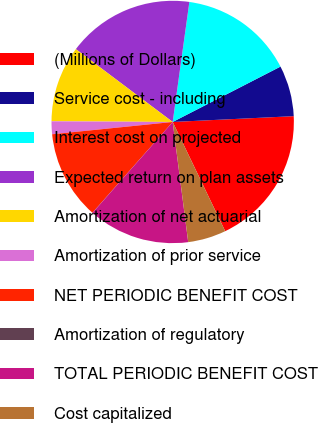Convert chart to OTSL. <chart><loc_0><loc_0><loc_500><loc_500><pie_chart><fcel>(Millions of Dollars)<fcel>Service cost - including<fcel>Interest cost on projected<fcel>Expected return on plan assets<fcel>Amortization of net actuarial<fcel>Amortization of prior service<fcel>NET PERIODIC BENEFIT COST<fcel>Amortization of regulatory<fcel>TOTAL PERIODIC BENEFIT COST<fcel>Cost capitalized<nl><fcel>18.63%<fcel>6.79%<fcel>15.25%<fcel>16.94%<fcel>10.17%<fcel>1.71%<fcel>11.86%<fcel>0.02%<fcel>13.55%<fcel>5.09%<nl></chart> 